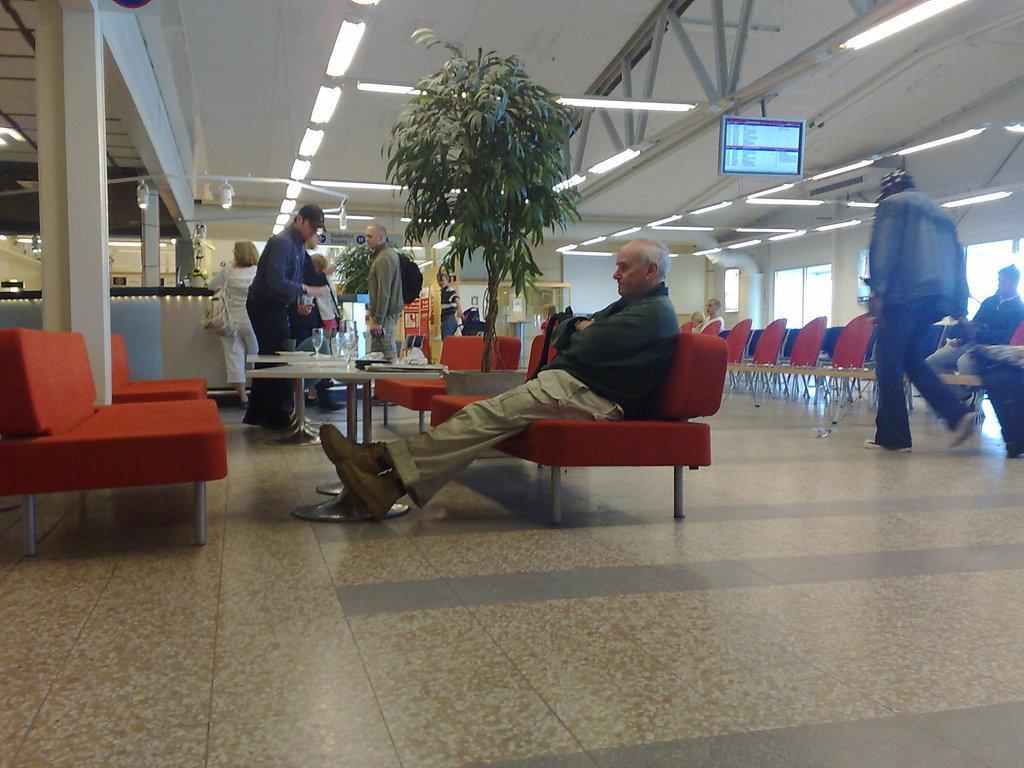Describe this image in one or two sentences. In this image I can see some chairs on the floor, some people sitting in the chair, some people walking, standing, a potted plant, a screen, false ceiling with some poles and lights, pillar on the left hand side, some tables with wine glasses. 